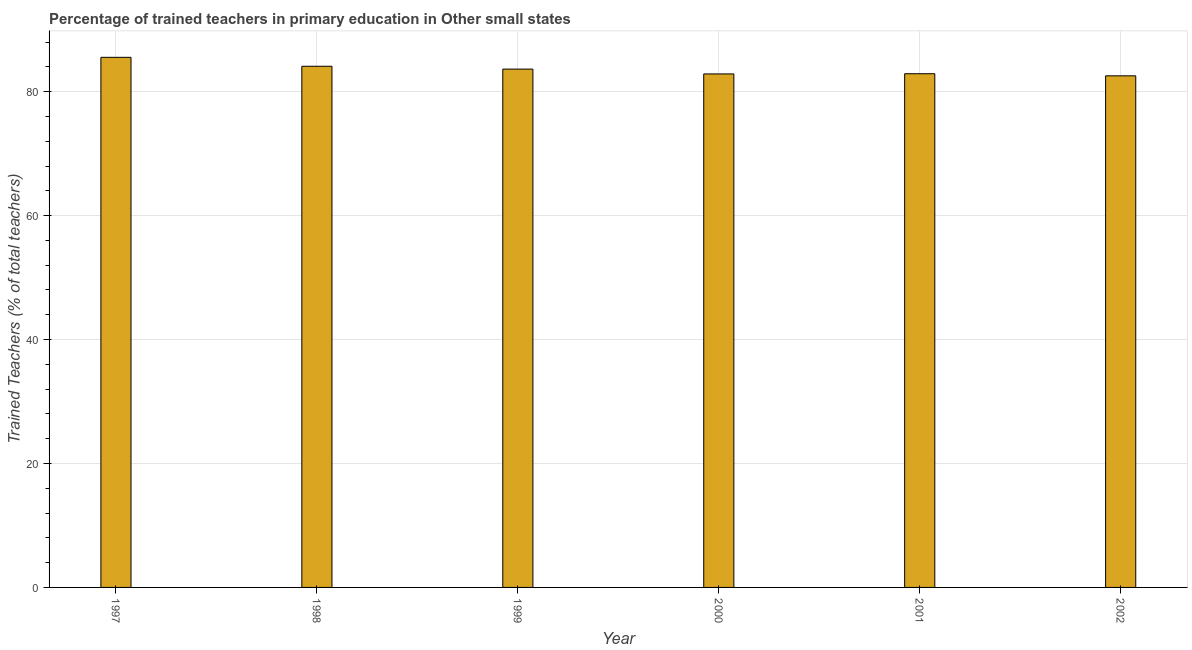Does the graph contain any zero values?
Your answer should be compact. No. Does the graph contain grids?
Your response must be concise. Yes. What is the title of the graph?
Provide a short and direct response. Percentage of trained teachers in primary education in Other small states. What is the label or title of the Y-axis?
Your answer should be compact. Trained Teachers (% of total teachers). What is the percentage of trained teachers in 1999?
Ensure brevity in your answer.  83.64. Across all years, what is the maximum percentage of trained teachers?
Make the answer very short. 85.54. Across all years, what is the minimum percentage of trained teachers?
Your response must be concise. 82.55. What is the sum of the percentage of trained teachers?
Keep it short and to the point. 501.59. What is the difference between the percentage of trained teachers in 1997 and 1998?
Provide a succinct answer. 1.44. What is the average percentage of trained teachers per year?
Ensure brevity in your answer.  83.6. What is the median percentage of trained teachers?
Your answer should be very brief. 83.27. In how many years, is the percentage of trained teachers greater than 40 %?
Your answer should be very brief. 6. What is the difference between the highest and the second highest percentage of trained teachers?
Ensure brevity in your answer.  1.44. Is the sum of the percentage of trained teachers in 2000 and 2001 greater than the maximum percentage of trained teachers across all years?
Your response must be concise. Yes. What is the difference between the highest and the lowest percentage of trained teachers?
Provide a short and direct response. 2.99. In how many years, is the percentage of trained teachers greater than the average percentage of trained teachers taken over all years?
Your response must be concise. 3. How many bars are there?
Give a very brief answer. 6. Are all the bars in the graph horizontal?
Give a very brief answer. No. How many years are there in the graph?
Your answer should be compact. 6. What is the difference between two consecutive major ticks on the Y-axis?
Give a very brief answer. 20. Are the values on the major ticks of Y-axis written in scientific E-notation?
Your answer should be compact. No. What is the Trained Teachers (% of total teachers) in 1997?
Your response must be concise. 85.54. What is the Trained Teachers (% of total teachers) in 1998?
Keep it short and to the point. 84.1. What is the Trained Teachers (% of total teachers) of 1999?
Give a very brief answer. 83.64. What is the Trained Teachers (% of total teachers) of 2000?
Make the answer very short. 82.86. What is the Trained Teachers (% of total teachers) in 2001?
Offer a terse response. 82.9. What is the Trained Teachers (% of total teachers) in 2002?
Provide a succinct answer. 82.55. What is the difference between the Trained Teachers (% of total teachers) in 1997 and 1998?
Give a very brief answer. 1.44. What is the difference between the Trained Teachers (% of total teachers) in 1997 and 1999?
Provide a short and direct response. 1.9. What is the difference between the Trained Teachers (% of total teachers) in 1997 and 2000?
Keep it short and to the point. 2.68. What is the difference between the Trained Teachers (% of total teachers) in 1997 and 2001?
Provide a short and direct response. 2.64. What is the difference between the Trained Teachers (% of total teachers) in 1997 and 2002?
Ensure brevity in your answer.  2.99. What is the difference between the Trained Teachers (% of total teachers) in 1998 and 1999?
Your answer should be very brief. 0.46. What is the difference between the Trained Teachers (% of total teachers) in 1998 and 2000?
Give a very brief answer. 1.23. What is the difference between the Trained Teachers (% of total teachers) in 1998 and 2001?
Your answer should be very brief. 1.2. What is the difference between the Trained Teachers (% of total teachers) in 1998 and 2002?
Ensure brevity in your answer.  1.54. What is the difference between the Trained Teachers (% of total teachers) in 1999 and 2000?
Offer a terse response. 0.78. What is the difference between the Trained Teachers (% of total teachers) in 1999 and 2001?
Ensure brevity in your answer.  0.75. What is the difference between the Trained Teachers (% of total teachers) in 1999 and 2002?
Provide a succinct answer. 1.09. What is the difference between the Trained Teachers (% of total teachers) in 2000 and 2001?
Make the answer very short. -0.03. What is the difference between the Trained Teachers (% of total teachers) in 2000 and 2002?
Your response must be concise. 0.31. What is the difference between the Trained Teachers (% of total teachers) in 2001 and 2002?
Offer a terse response. 0.34. What is the ratio of the Trained Teachers (% of total teachers) in 1997 to that in 2000?
Provide a short and direct response. 1.03. What is the ratio of the Trained Teachers (% of total teachers) in 1997 to that in 2001?
Your answer should be very brief. 1.03. What is the ratio of the Trained Teachers (% of total teachers) in 1997 to that in 2002?
Your answer should be compact. 1.04. What is the ratio of the Trained Teachers (% of total teachers) in 1998 to that in 1999?
Offer a very short reply. 1. What is the ratio of the Trained Teachers (% of total teachers) in 1998 to that in 2000?
Your answer should be very brief. 1.01. What is the ratio of the Trained Teachers (% of total teachers) in 1999 to that in 2001?
Offer a terse response. 1.01. What is the ratio of the Trained Teachers (% of total teachers) in 1999 to that in 2002?
Your response must be concise. 1.01. What is the ratio of the Trained Teachers (% of total teachers) in 2000 to that in 2001?
Offer a terse response. 1. What is the ratio of the Trained Teachers (% of total teachers) in 2001 to that in 2002?
Offer a very short reply. 1. 